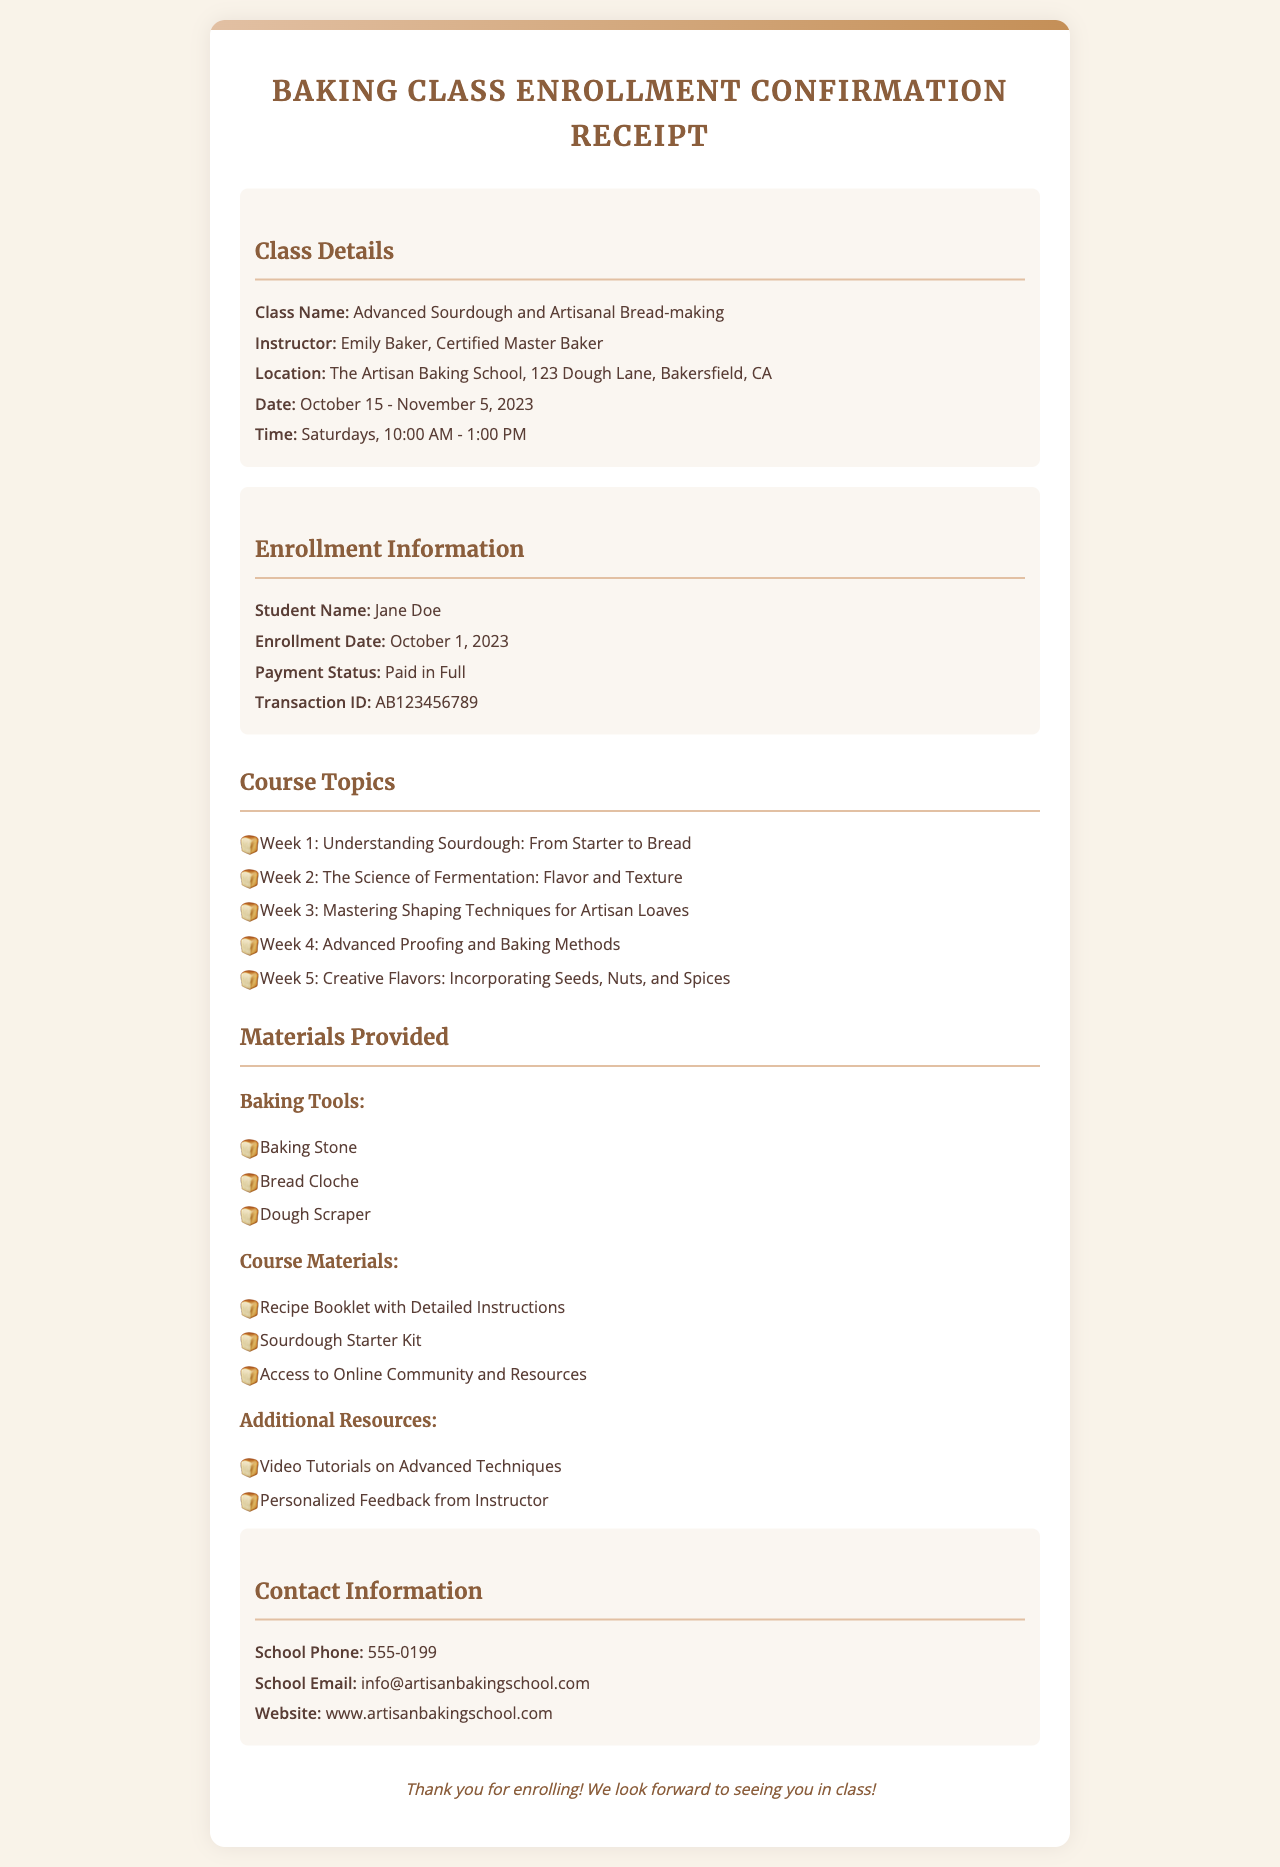What is the class name? The class name is explicitly mentioned in the class details section of the document.
Answer: Advanced Sourdough and Artisanal Bread-making Who is the instructor? The instructor's name is provided in the class details section of the document.
Answer: Emily Baker, Certified Master Baker What is the location of the class? The location can be found in the class details section.
Answer: The Artisan Baking School, 123 Dough Lane, Bakersfield, CA How many weeks does the course run? The duration of the course is indicated in the date section.
Answer: 3 weeks What is the payment status? The payment status is mentioned in the enrollment information section.
Answer: Paid in Full List one of the baking tools provided. The baking tools are listed under the materials provided section, where specific items are mentioned.
Answer: Baking Stone What additional resource is offered besides the recipe booklet? The additional resources mentioned in the document include a range of items, requiring understanding of the document.
Answer: Video Tutorials on Advanced Techniques When does the class meet? The days and times the class meets are outlined in the details section.
Answer: Saturdays, 10:00 AM - 1:00 PM What is the student’s name? The student's name can be found in the enrollment information section of the document.
Answer: Jane Doe 